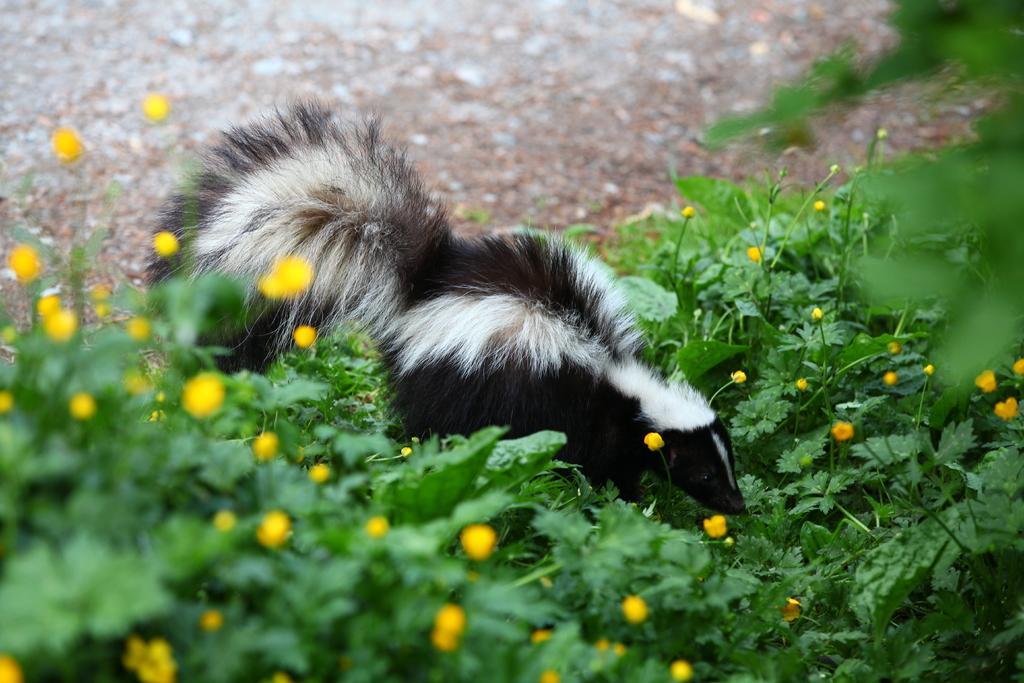How would you summarize this image in a sentence or two? In this picture I can see at the bottom there are flowers and plants. In the middle there is an animal in black and white color. 